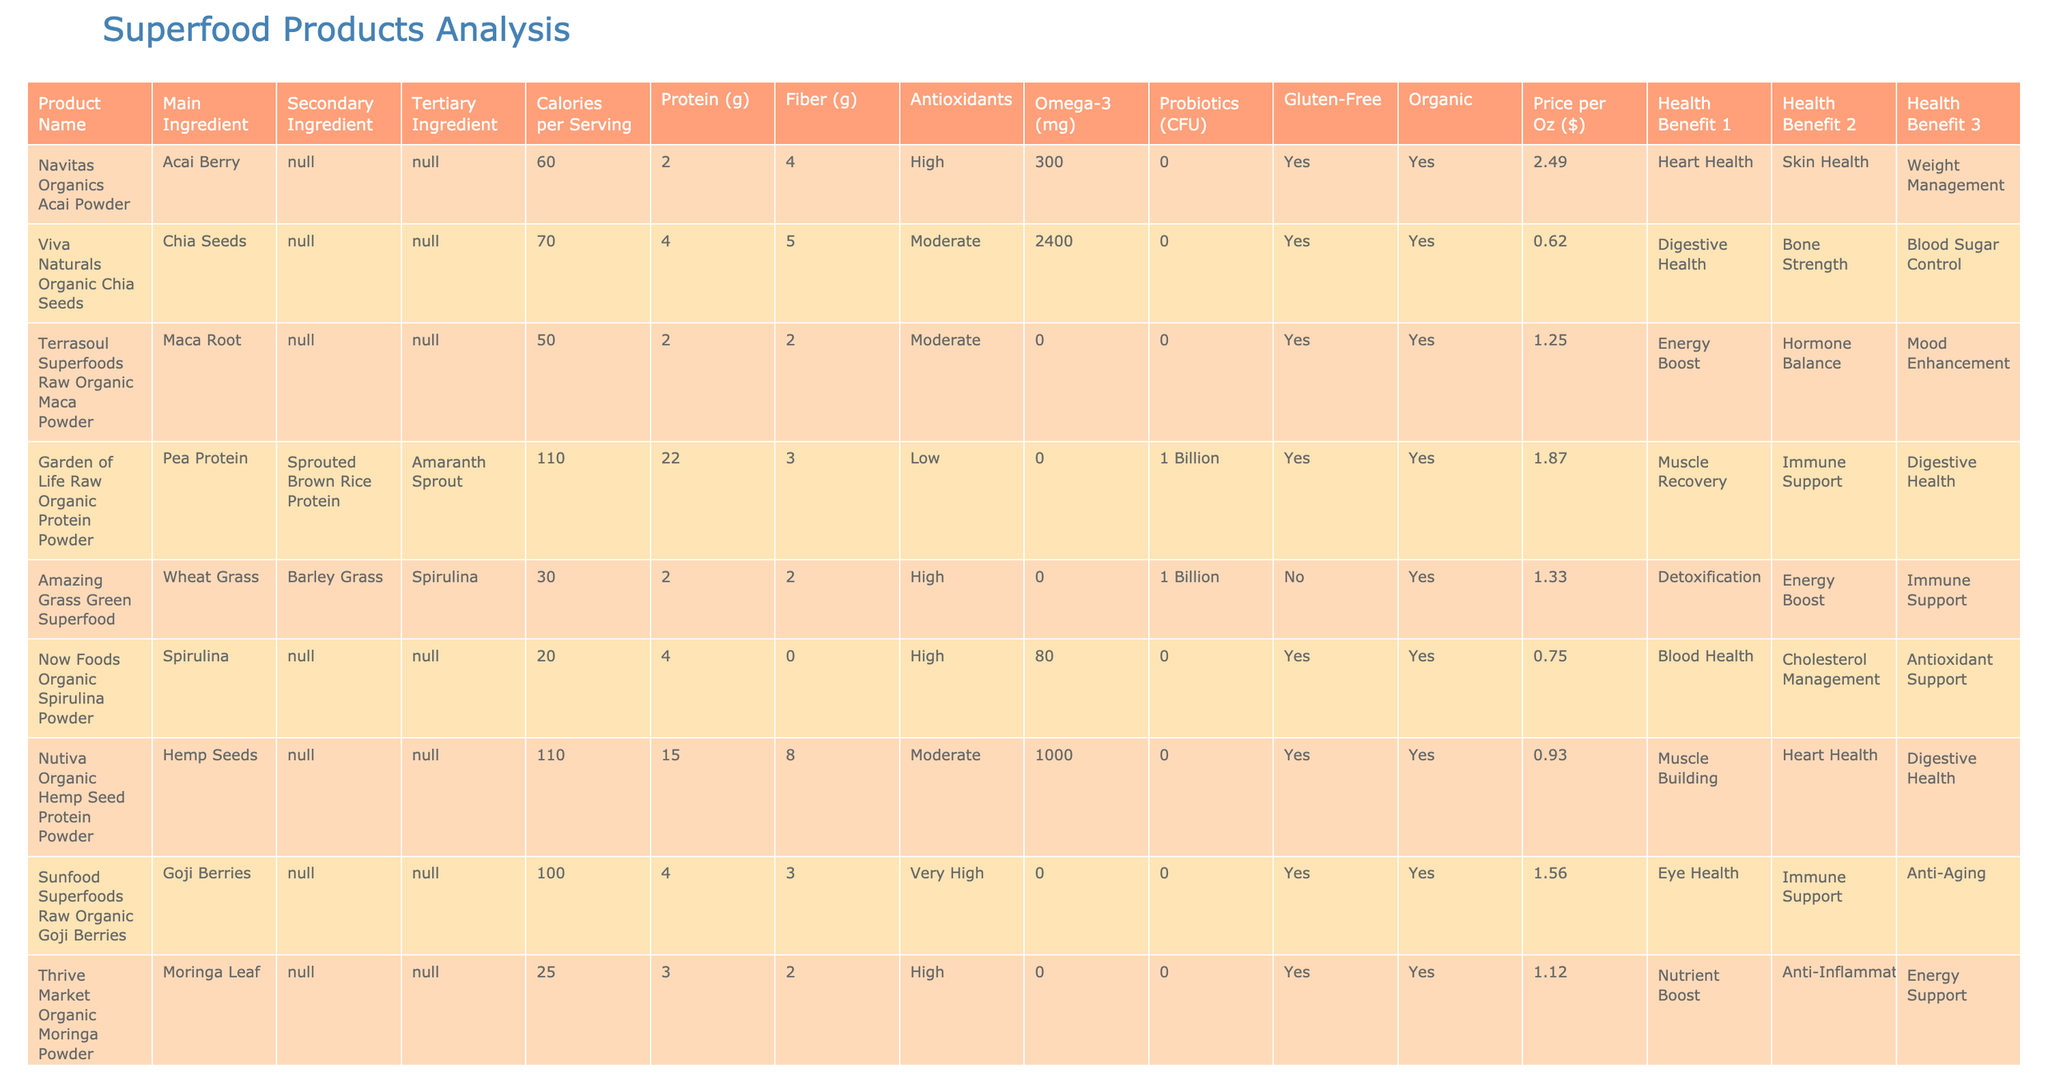What is the main ingredient in Navitas Organics Acai Powder? According to the table, the main ingredient listed for Navitas Organics Acai Powder is Acai Berry.
Answer: Acai Berry How many grams of protein are in Garden of Life Raw Organic Protein Powder? The table shows that Garden of Life Raw Organic Protein Powder has 22 grams of protein per serving.
Answer: 22 grams Which product has the highest calorie content? By comparing the Calories per Serving column, Natierra Nature's All Foods Organic Freeze-Dried Blueberries is identified as having the highest calorie content at 130 calories per serving.
Answer: 130 calories Is Amazing Grass Green Superfood gluten-free? The table indicates that Amazing Grass Green Superfood is not gluten-free, as marked under the Gluten-Free column.
Answer: No What is the total fiber content of Viva Naturals Organic Chia Seeds and Healthworks Turmeric Powder? To find the total fiber content, we add the fiber in Viva Naturals Organic Chia Seeds (5 grams) and Healthworks Turmeric Powder (2 grams), which equals 7 grams of fiber.
Answer: 7 grams Which product is known for “Muscle Building” as a health benefit? By reviewing the Health Benefit 1 column, Nutiva Organic Hemp Seed Protein Powder is associated with Muscle Building as one of its health benefits.
Answer: Nutiva Organic Hemp Seed Protein Powder What is the price difference per ounce between Purely Elizabeth Organic Ancient Grain Granola and Nutiva Organic Hemp Seed Protein Powder? Purely Elizabeth Organic Ancient Grain Granola costs $0.75 per ounce and Nutiva Organic Hemp Seed Protein Powder is $0.93 per ounce. The price difference is calculated as $0.93 - $0.75 = $0.18.
Answer: $0.18 How many products have “High” levels of antioxidants? By counting the entries in the Antioxidants column that state “High,” we find that 5 products have high levels of antioxidants: Navitas Organics Acai Powder, Now Foods Organic Spirulina Powder, Sunfood Superfoods Raw Organic Goji Berries, Thrive Market Organic Moringa Powder, and Healthworks Turmeric Powder.
Answer: 5 products What is the average amount of Omega-3 in the products listed? The total Omega-3 content is summed as 300 + 2400 + 0 + 0 + 0 + 80 + 1000 + 0 + 0 + 0 + 200 = 3980 mg. There are 11 products listed, so the average is 3980 mg / 11 ≈ 361.82 mg.
Answer: 361.82 mg Which superfood has the lowest calorie count? Comparing the Calories per Serving column, Four Sigmatic Organic Mushroom Blend has the lowest calories with only 10 calories per serving.
Answer: 10 calories Is there any product that combines Chia Seeds and Barley Grass as ingredients? After examining the table, it is clear that no product combines Chia Seeds and Barley Grass; they appear in separate products.
Answer: No 